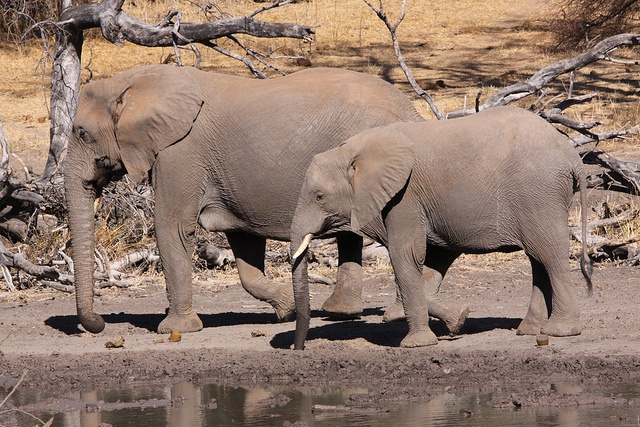Describe the objects in this image and their specific colors. I can see elephant in black, darkgray, and gray tones and elephant in black, darkgray, and gray tones in this image. 